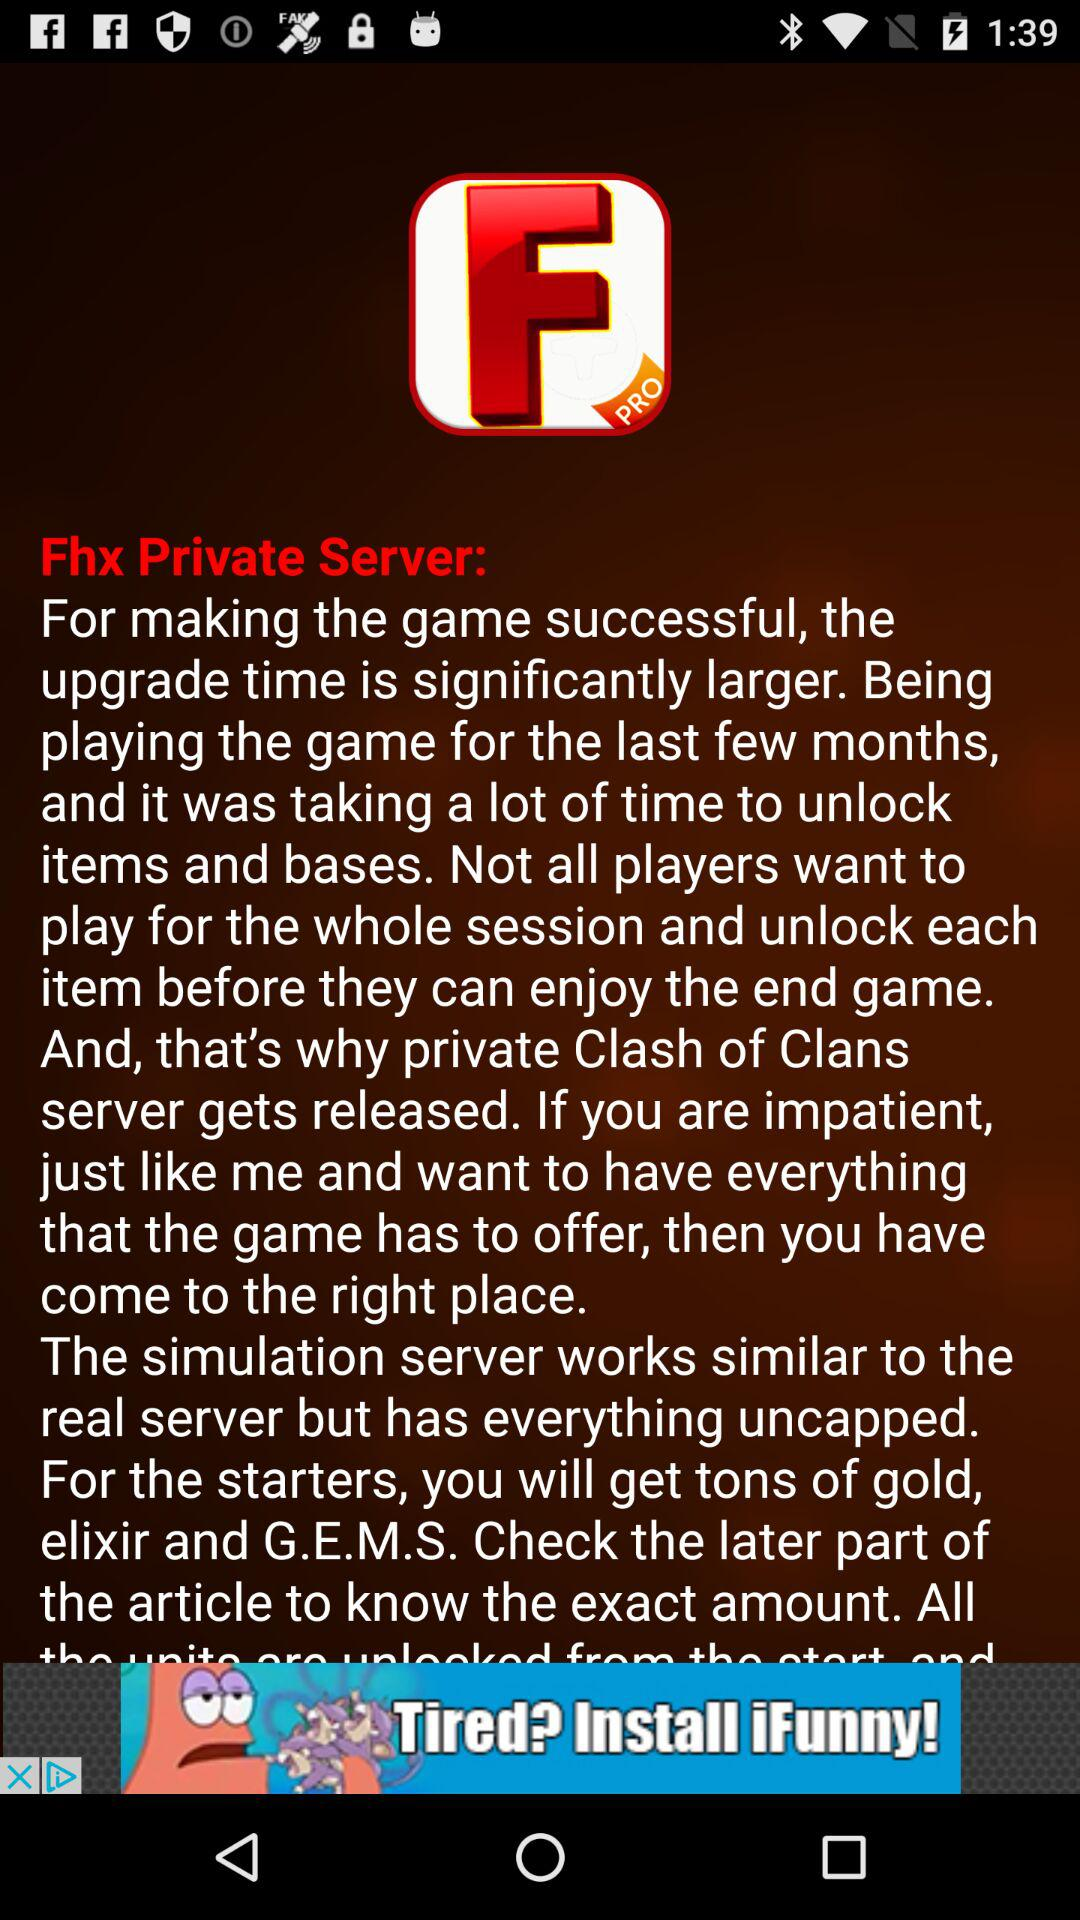What is the name of the application? The name of the application is "Fhx Private Server". 